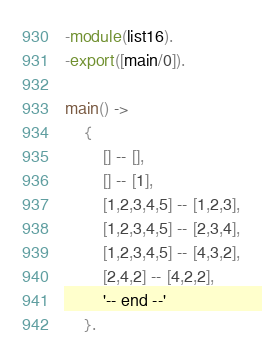<code> <loc_0><loc_0><loc_500><loc_500><_Erlang_>-module(list16).
-export([main/0]).

main() ->
	{
		[] -- [],
		[] -- [1],
		[1,2,3,4,5] -- [1,2,3],
		[1,2,3,4,5] -- [2,3,4],
		[1,2,3,4,5] -- [4,3,2],
		[2,4,2] -- [4,2,2],
		'-- end --'
	}.
</code> 